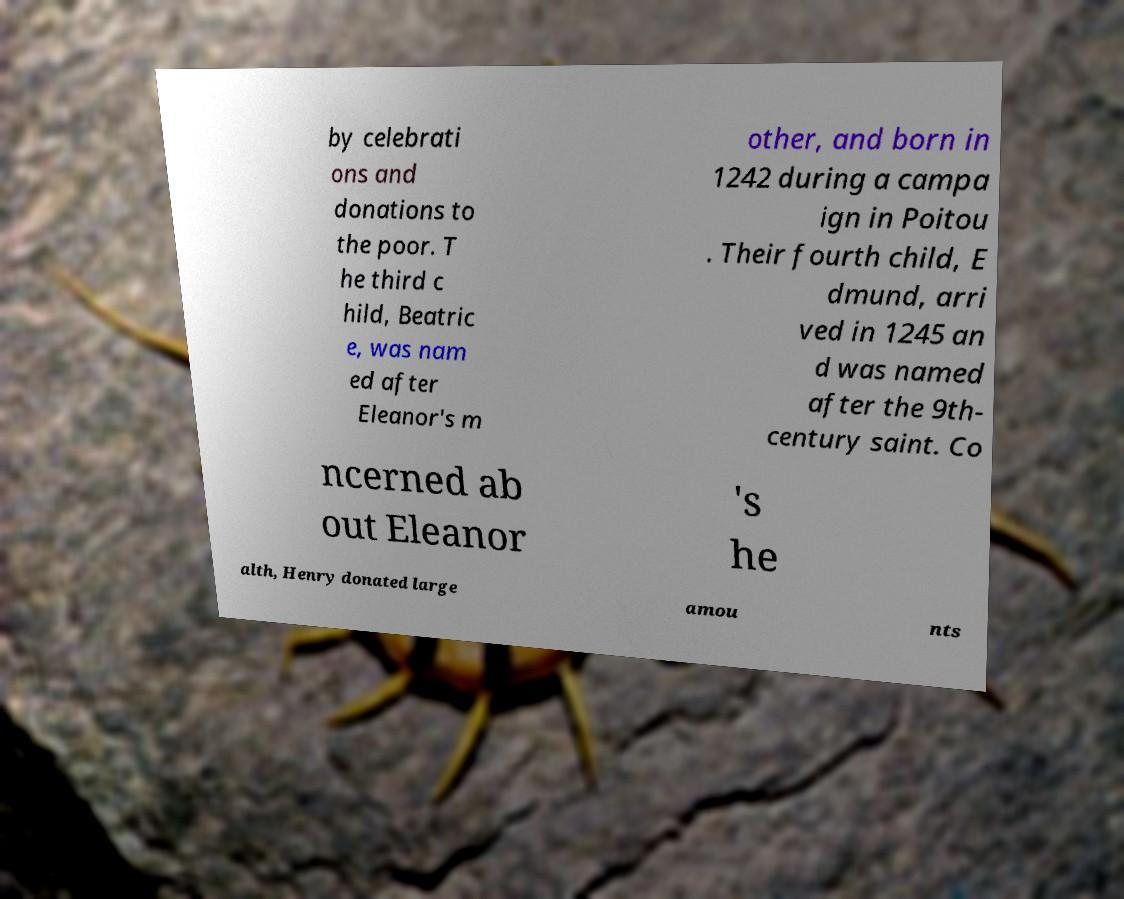Can you read and provide the text displayed in the image?This photo seems to have some interesting text. Can you extract and type it out for me? by celebrati ons and donations to the poor. T he third c hild, Beatric e, was nam ed after Eleanor's m other, and born in 1242 during a campa ign in Poitou . Their fourth child, E dmund, arri ved in 1245 an d was named after the 9th- century saint. Co ncerned ab out Eleanor 's he alth, Henry donated large amou nts 